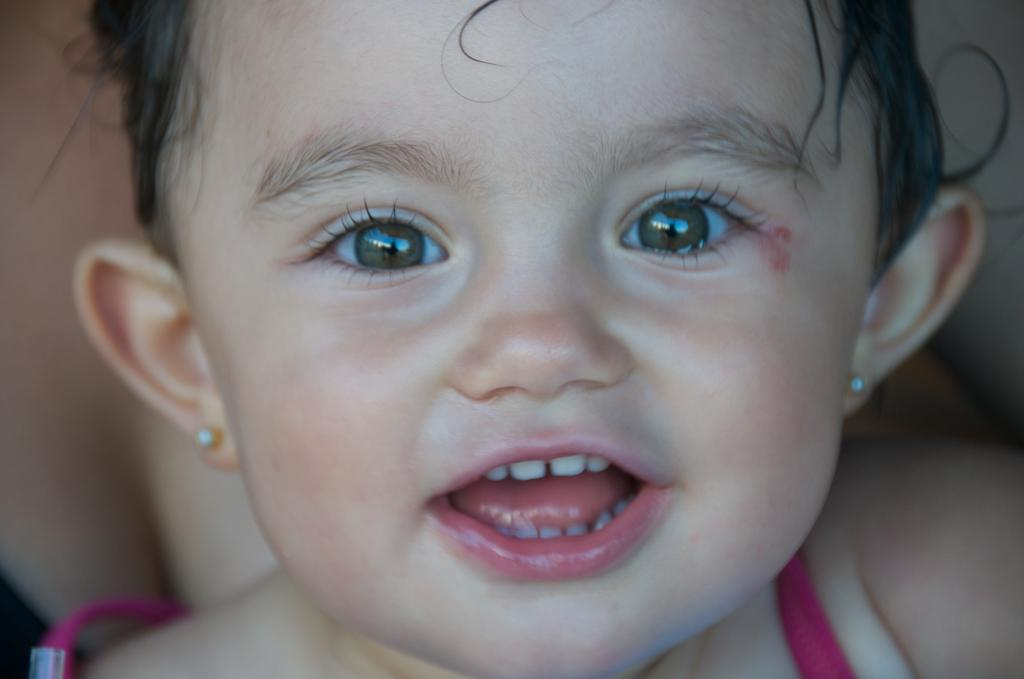What is the main subject of the image? There is a baby in the image. What is the baby wearing? The baby is wearing a pink dress. What idea does the baby have about the bears in the image? There are no bears present in the image, so the baby cannot have an idea about them. 